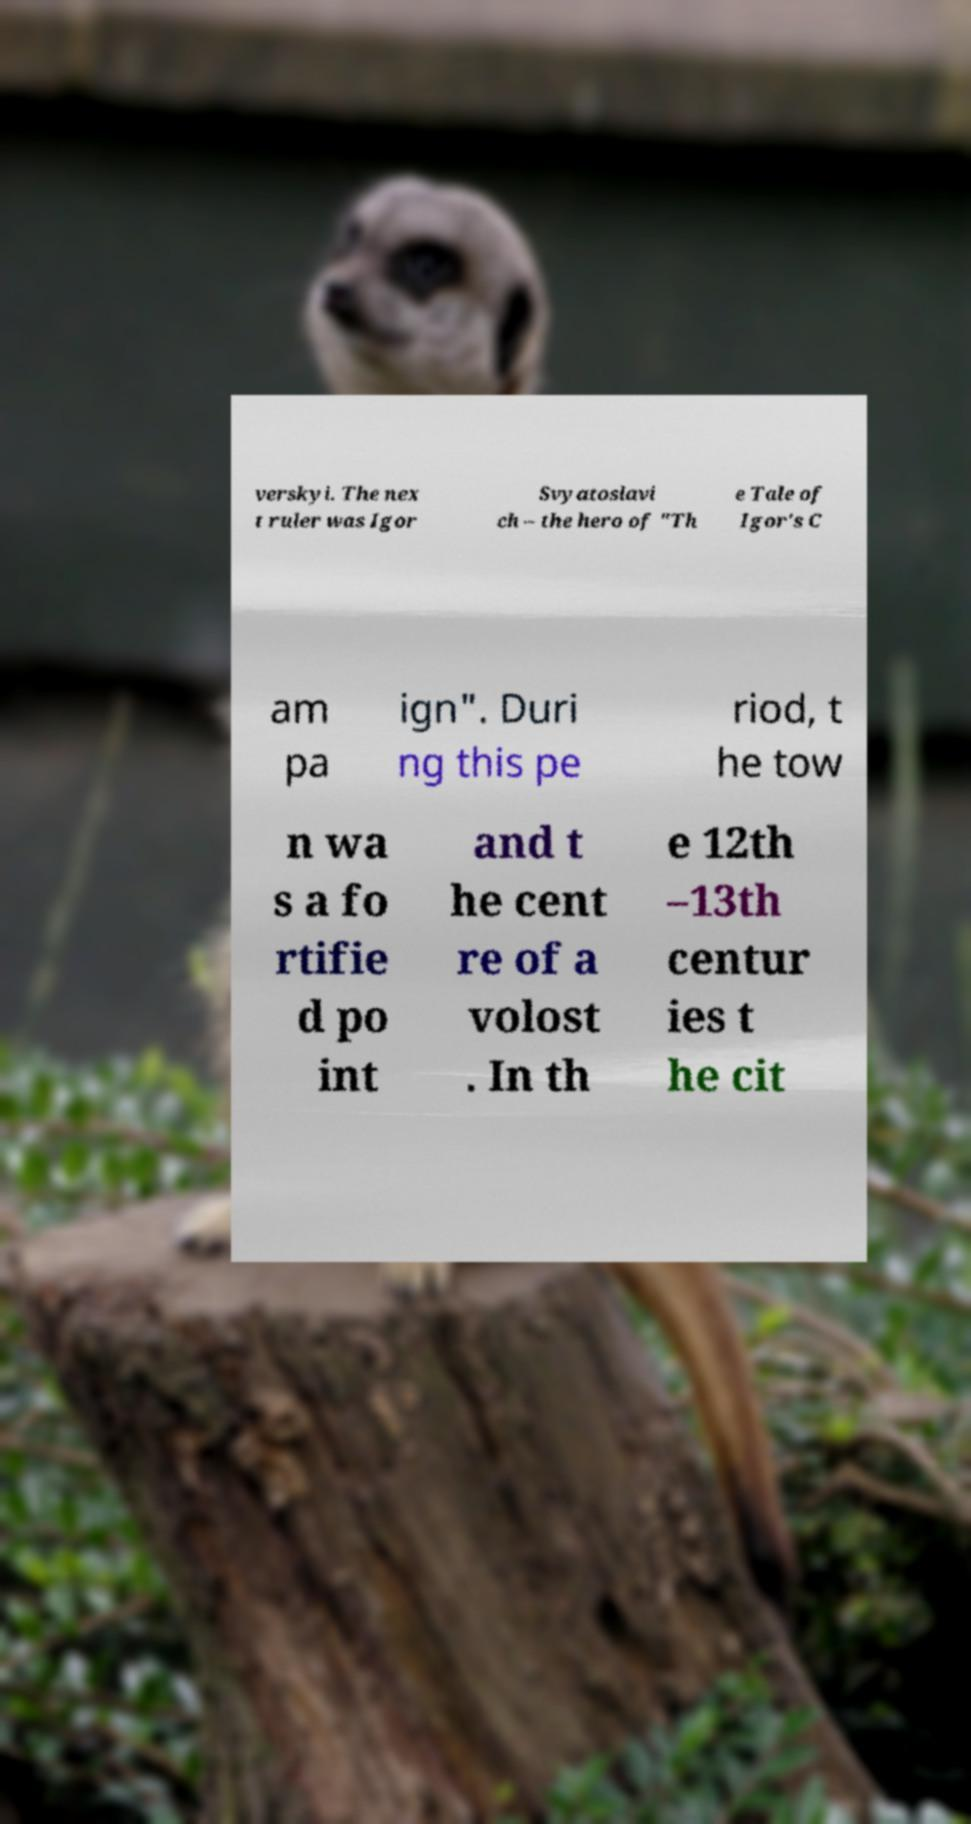There's text embedded in this image that I need extracted. Can you transcribe it verbatim? verskyi. The nex t ruler was Igor Svyatoslavi ch – the hero of "Th e Tale of Igor's C am pa ign". Duri ng this pe riod, t he tow n wa s a fo rtifie d po int and t he cent re of a volost . In th e 12th –13th centur ies t he cit 